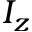<formula> <loc_0><loc_0><loc_500><loc_500>I _ { z }</formula> 